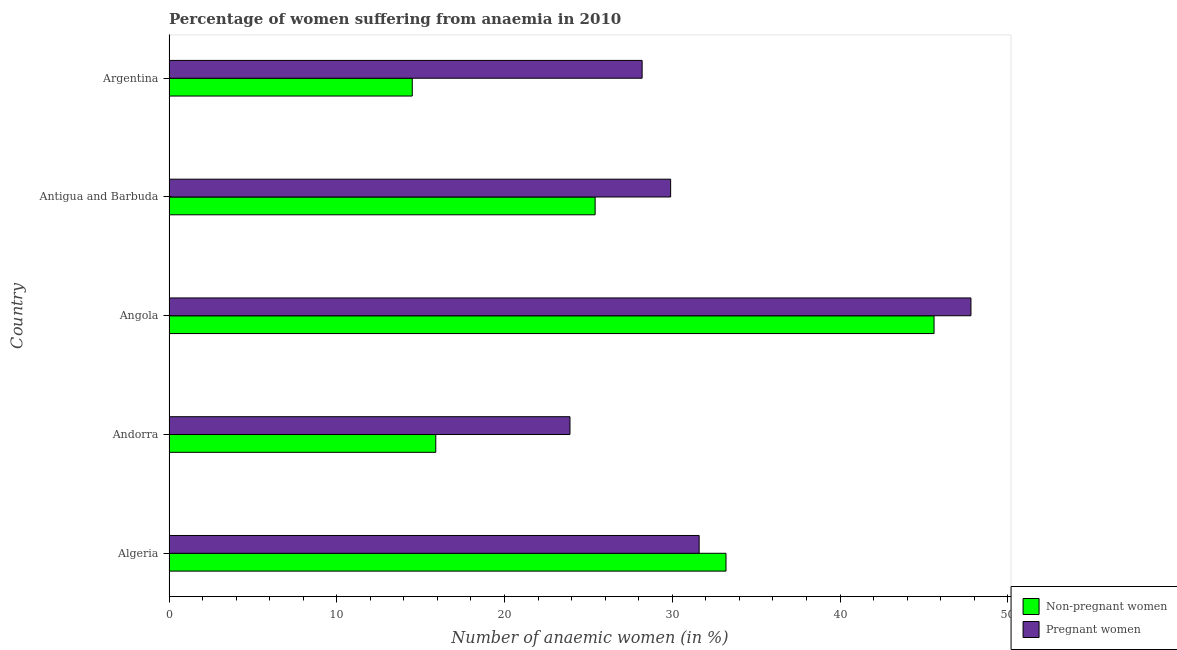Are the number of bars per tick equal to the number of legend labels?
Keep it short and to the point. Yes. Are the number of bars on each tick of the Y-axis equal?
Offer a terse response. Yes. How many bars are there on the 2nd tick from the top?
Offer a terse response. 2. How many bars are there on the 3rd tick from the bottom?
Keep it short and to the point. 2. What is the label of the 2nd group of bars from the top?
Offer a terse response. Antigua and Barbuda. In how many cases, is the number of bars for a given country not equal to the number of legend labels?
Your answer should be very brief. 0. What is the percentage of pregnant anaemic women in Argentina?
Your response must be concise. 28.2. Across all countries, what is the maximum percentage of non-pregnant anaemic women?
Your response must be concise. 45.6. Across all countries, what is the minimum percentage of pregnant anaemic women?
Ensure brevity in your answer.  23.9. In which country was the percentage of pregnant anaemic women maximum?
Offer a very short reply. Angola. In which country was the percentage of pregnant anaemic women minimum?
Provide a short and direct response. Andorra. What is the total percentage of non-pregnant anaemic women in the graph?
Your answer should be very brief. 134.6. What is the difference between the percentage of non-pregnant anaemic women in Argentina and the percentage of pregnant anaemic women in Algeria?
Offer a terse response. -17.1. What is the average percentage of pregnant anaemic women per country?
Your answer should be very brief. 32.28. What is the difference between the percentage of non-pregnant anaemic women and percentage of pregnant anaemic women in Argentina?
Provide a short and direct response. -13.7. What is the ratio of the percentage of non-pregnant anaemic women in Algeria to that in Antigua and Barbuda?
Your response must be concise. 1.31. Is the percentage of non-pregnant anaemic women in Antigua and Barbuda less than that in Argentina?
Offer a terse response. No. What is the difference between the highest and the second highest percentage of pregnant anaemic women?
Provide a short and direct response. 16.2. What is the difference between the highest and the lowest percentage of non-pregnant anaemic women?
Offer a terse response. 31.1. Is the sum of the percentage of non-pregnant anaemic women in Angola and Antigua and Barbuda greater than the maximum percentage of pregnant anaemic women across all countries?
Your answer should be compact. Yes. What does the 2nd bar from the top in Angola represents?
Provide a short and direct response. Non-pregnant women. What does the 1st bar from the bottom in Algeria represents?
Offer a terse response. Non-pregnant women. How many bars are there?
Your answer should be compact. 10. Are all the bars in the graph horizontal?
Your answer should be compact. Yes. Are the values on the major ticks of X-axis written in scientific E-notation?
Give a very brief answer. No. Does the graph contain any zero values?
Make the answer very short. No. Does the graph contain grids?
Your response must be concise. No. Where does the legend appear in the graph?
Your answer should be compact. Bottom right. How many legend labels are there?
Offer a very short reply. 2. What is the title of the graph?
Ensure brevity in your answer.  Percentage of women suffering from anaemia in 2010. Does "Working only" appear as one of the legend labels in the graph?
Provide a succinct answer. No. What is the label or title of the X-axis?
Your answer should be compact. Number of anaemic women (in %). What is the Number of anaemic women (in %) in Non-pregnant women in Algeria?
Give a very brief answer. 33.2. What is the Number of anaemic women (in %) in Pregnant women in Algeria?
Keep it short and to the point. 31.6. What is the Number of anaemic women (in %) of Non-pregnant women in Andorra?
Your response must be concise. 15.9. What is the Number of anaemic women (in %) in Pregnant women in Andorra?
Offer a terse response. 23.9. What is the Number of anaemic women (in %) of Non-pregnant women in Angola?
Your answer should be compact. 45.6. What is the Number of anaemic women (in %) of Pregnant women in Angola?
Offer a very short reply. 47.8. What is the Number of anaemic women (in %) of Non-pregnant women in Antigua and Barbuda?
Give a very brief answer. 25.4. What is the Number of anaemic women (in %) of Pregnant women in Antigua and Barbuda?
Your answer should be compact. 29.9. What is the Number of anaemic women (in %) in Non-pregnant women in Argentina?
Offer a terse response. 14.5. What is the Number of anaemic women (in %) in Pregnant women in Argentina?
Make the answer very short. 28.2. Across all countries, what is the maximum Number of anaemic women (in %) in Non-pregnant women?
Give a very brief answer. 45.6. Across all countries, what is the maximum Number of anaemic women (in %) in Pregnant women?
Provide a succinct answer. 47.8. Across all countries, what is the minimum Number of anaemic women (in %) in Pregnant women?
Your answer should be very brief. 23.9. What is the total Number of anaemic women (in %) in Non-pregnant women in the graph?
Offer a very short reply. 134.6. What is the total Number of anaemic women (in %) of Pregnant women in the graph?
Your answer should be compact. 161.4. What is the difference between the Number of anaemic women (in %) in Non-pregnant women in Algeria and that in Andorra?
Keep it short and to the point. 17.3. What is the difference between the Number of anaemic women (in %) in Pregnant women in Algeria and that in Andorra?
Offer a very short reply. 7.7. What is the difference between the Number of anaemic women (in %) in Pregnant women in Algeria and that in Angola?
Your response must be concise. -16.2. What is the difference between the Number of anaemic women (in %) in Non-pregnant women in Algeria and that in Antigua and Barbuda?
Give a very brief answer. 7.8. What is the difference between the Number of anaemic women (in %) in Non-pregnant women in Algeria and that in Argentina?
Make the answer very short. 18.7. What is the difference between the Number of anaemic women (in %) of Pregnant women in Algeria and that in Argentina?
Give a very brief answer. 3.4. What is the difference between the Number of anaemic women (in %) of Non-pregnant women in Andorra and that in Angola?
Keep it short and to the point. -29.7. What is the difference between the Number of anaemic women (in %) in Pregnant women in Andorra and that in Angola?
Provide a short and direct response. -23.9. What is the difference between the Number of anaemic women (in %) of Non-pregnant women in Andorra and that in Antigua and Barbuda?
Ensure brevity in your answer.  -9.5. What is the difference between the Number of anaemic women (in %) in Non-pregnant women in Andorra and that in Argentina?
Keep it short and to the point. 1.4. What is the difference between the Number of anaemic women (in %) in Pregnant women in Andorra and that in Argentina?
Offer a very short reply. -4.3. What is the difference between the Number of anaemic women (in %) in Non-pregnant women in Angola and that in Antigua and Barbuda?
Make the answer very short. 20.2. What is the difference between the Number of anaemic women (in %) in Non-pregnant women in Angola and that in Argentina?
Ensure brevity in your answer.  31.1. What is the difference between the Number of anaemic women (in %) of Pregnant women in Angola and that in Argentina?
Keep it short and to the point. 19.6. What is the difference between the Number of anaemic women (in %) in Non-pregnant women in Algeria and the Number of anaemic women (in %) in Pregnant women in Angola?
Provide a short and direct response. -14.6. What is the difference between the Number of anaemic women (in %) in Non-pregnant women in Andorra and the Number of anaemic women (in %) in Pregnant women in Angola?
Your answer should be very brief. -31.9. What is the difference between the Number of anaemic women (in %) of Non-pregnant women in Andorra and the Number of anaemic women (in %) of Pregnant women in Argentina?
Your response must be concise. -12.3. What is the difference between the Number of anaemic women (in %) in Non-pregnant women in Angola and the Number of anaemic women (in %) in Pregnant women in Antigua and Barbuda?
Ensure brevity in your answer.  15.7. What is the difference between the Number of anaemic women (in %) of Non-pregnant women in Angola and the Number of anaemic women (in %) of Pregnant women in Argentina?
Keep it short and to the point. 17.4. What is the average Number of anaemic women (in %) in Non-pregnant women per country?
Your answer should be compact. 26.92. What is the average Number of anaemic women (in %) of Pregnant women per country?
Give a very brief answer. 32.28. What is the difference between the Number of anaemic women (in %) in Non-pregnant women and Number of anaemic women (in %) in Pregnant women in Andorra?
Your answer should be very brief. -8. What is the difference between the Number of anaemic women (in %) of Non-pregnant women and Number of anaemic women (in %) of Pregnant women in Argentina?
Provide a short and direct response. -13.7. What is the ratio of the Number of anaemic women (in %) in Non-pregnant women in Algeria to that in Andorra?
Offer a terse response. 2.09. What is the ratio of the Number of anaemic women (in %) of Pregnant women in Algeria to that in Andorra?
Give a very brief answer. 1.32. What is the ratio of the Number of anaemic women (in %) in Non-pregnant women in Algeria to that in Angola?
Offer a terse response. 0.73. What is the ratio of the Number of anaemic women (in %) in Pregnant women in Algeria to that in Angola?
Your answer should be very brief. 0.66. What is the ratio of the Number of anaemic women (in %) of Non-pregnant women in Algeria to that in Antigua and Barbuda?
Offer a terse response. 1.31. What is the ratio of the Number of anaemic women (in %) of Pregnant women in Algeria to that in Antigua and Barbuda?
Offer a very short reply. 1.06. What is the ratio of the Number of anaemic women (in %) in Non-pregnant women in Algeria to that in Argentina?
Offer a very short reply. 2.29. What is the ratio of the Number of anaemic women (in %) in Pregnant women in Algeria to that in Argentina?
Your answer should be very brief. 1.12. What is the ratio of the Number of anaemic women (in %) of Non-pregnant women in Andorra to that in Angola?
Give a very brief answer. 0.35. What is the ratio of the Number of anaemic women (in %) in Pregnant women in Andorra to that in Angola?
Provide a succinct answer. 0.5. What is the ratio of the Number of anaemic women (in %) in Non-pregnant women in Andorra to that in Antigua and Barbuda?
Offer a very short reply. 0.63. What is the ratio of the Number of anaemic women (in %) in Pregnant women in Andorra to that in Antigua and Barbuda?
Ensure brevity in your answer.  0.8. What is the ratio of the Number of anaemic women (in %) in Non-pregnant women in Andorra to that in Argentina?
Your answer should be very brief. 1.1. What is the ratio of the Number of anaemic women (in %) in Pregnant women in Andorra to that in Argentina?
Keep it short and to the point. 0.85. What is the ratio of the Number of anaemic women (in %) in Non-pregnant women in Angola to that in Antigua and Barbuda?
Make the answer very short. 1.8. What is the ratio of the Number of anaemic women (in %) in Pregnant women in Angola to that in Antigua and Barbuda?
Ensure brevity in your answer.  1.6. What is the ratio of the Number of anaemic women (in %) in Non-pregnant women in Angola to that in Argentina?
Provide a short and direct response. 3.14. What is the ratio of the Number of anaemic women (in %) in Pregnant women in Angola to that in Argentina?
Your answer should be compact. 1.7. What is the ratio of the Number of anaemic women (in %) in Non-pregnant women in Antigua and Barbuda to that in Argentina?
Provide a short and direct response. 1.75. What is the ratio of the Number of anaemic women (in %) in Pregnant women in Antigua and Barbuda to that in Argentina?
Ensure brevity in your answer.  1.06. What is the difference between the highest and the second highest Number of anaemic women (in %) of Pregnant women?
Your response must be concise. 16.2. What is the difference between the highest and the lowest Number of anaemic women (in %) of Non-pregnant women?
Offer a very short reply. 31.1. What is the difference between the highest and the lowest Number of anaemic women (in %) of Pregnant women?
Ensure brevity in your answer.  23.9. 